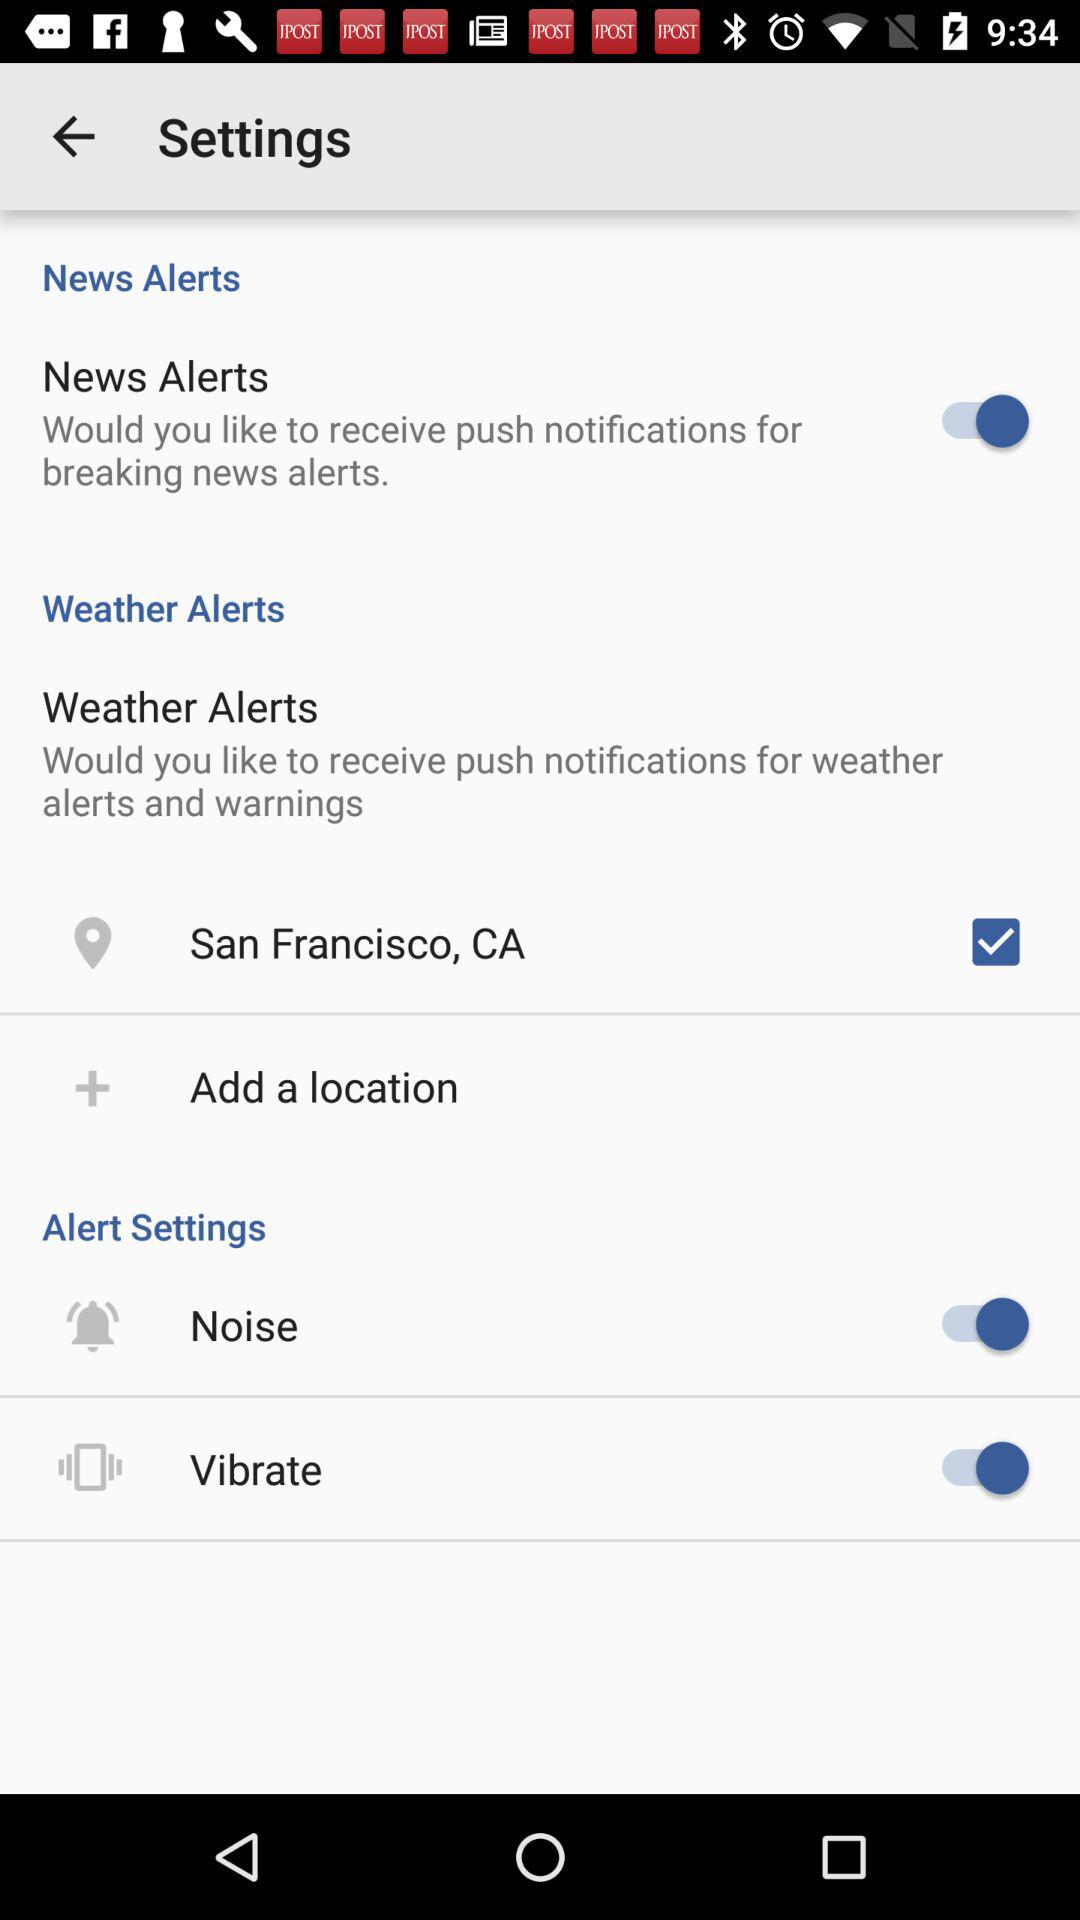What is the current location? The current location is San Francisco, CA. 